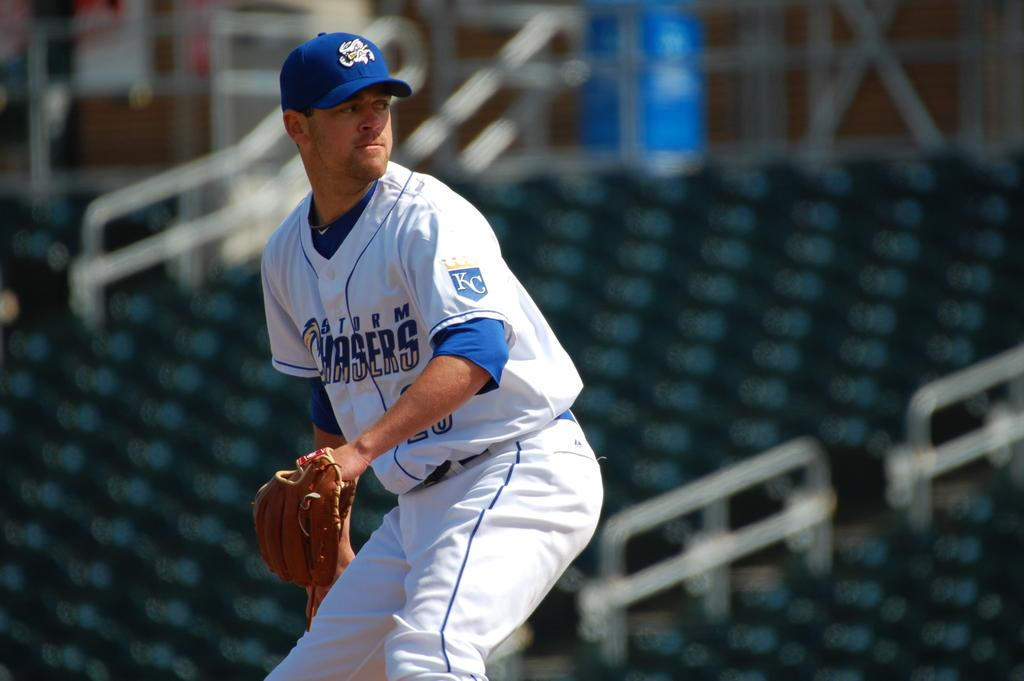Provide a one-sentence caption for the provided image. A bowler gets ready to throw the ball for the Chasers. 